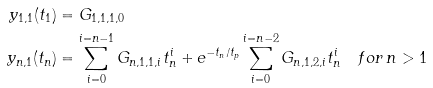<formula> <loc_0><loc_0><loc_500><loc_500>y _ { 1 , 1 } ( t _ { 1 } ) & = G _ { 1 , 1 , 1 , 0 } \\ y _ { n , 1 } ( t _ { n } ) & = \sum _ { i = 0 } ^ { i = n - 1 } G _ { n , 1 , 1 , i } t _ { n } ^ { i } + e ^ { - t _ { n } / t _ { p } } \sum _ { i = 0 } ^ { i = n - 2 } G _ { n , 1 , 2 , i } t _ { n } ^ { i } \quad f o r \, n > 1</formula> 